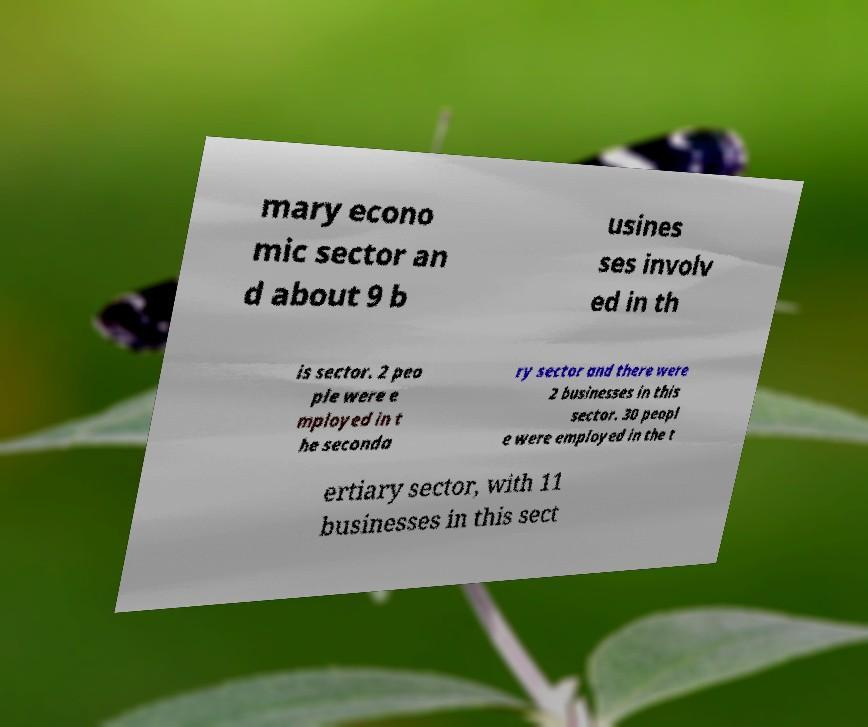What messages or text are displayed in this image? I need them in a readable, typed format. mary econo mic sector an d about 9 b usines ses involv ed in th is sector. 2 peo ple were e mployed in t he seconda ry sector and there were 2 businesses in this sector. 30 peopl e were employed in the t ertiary sector, with 11 businesses in this sect 